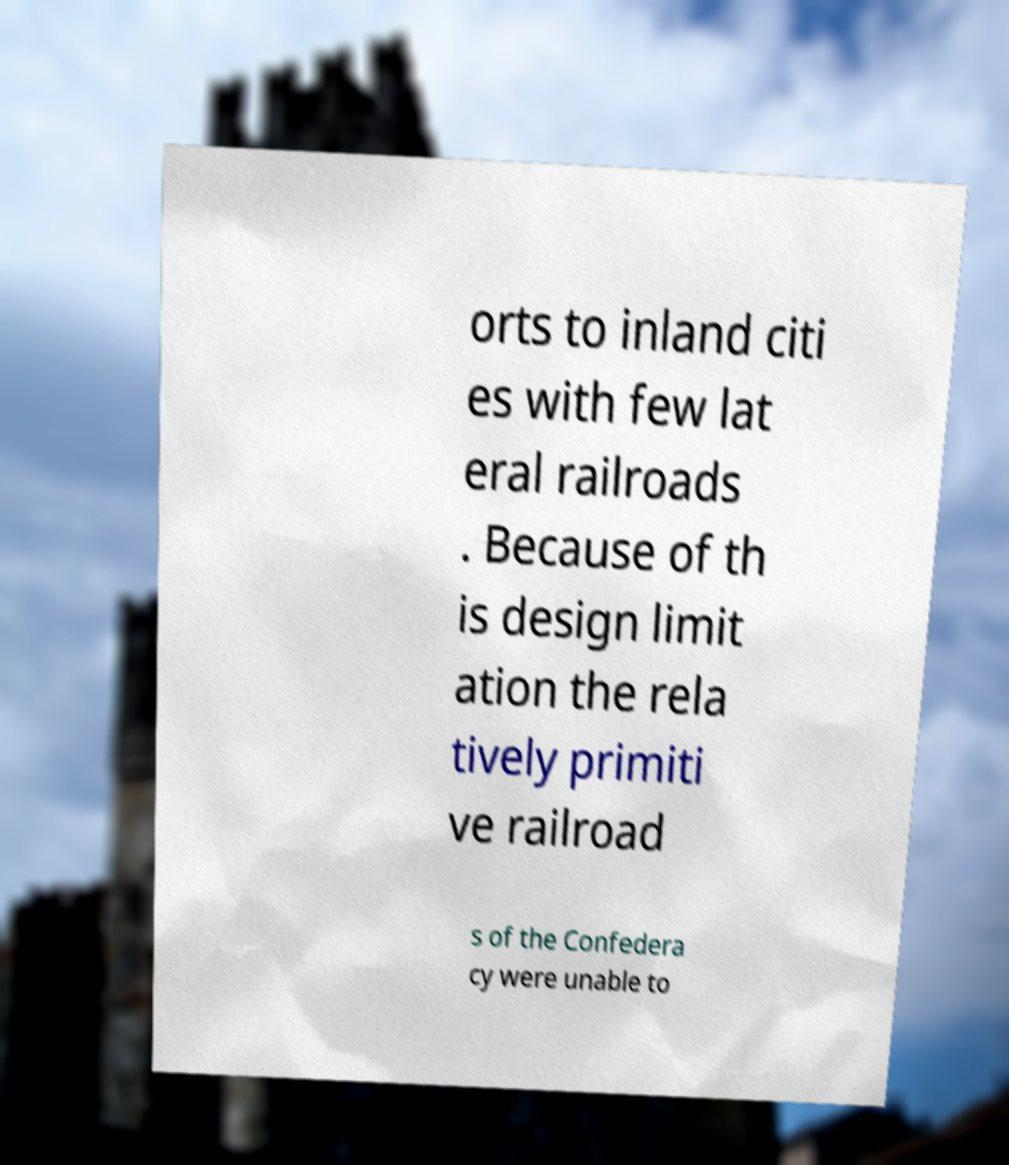Can you accurately transcribe the text from the provided image for me? orts to inland citi es with few lat eral railroads . Because of th is design limit ation the rela tively primiti ve railroad s of the Confedera cy were unable to 